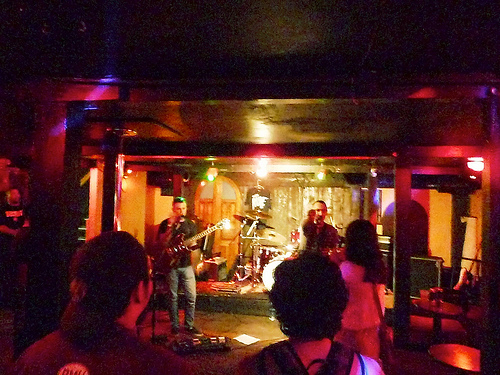<image>
Is there a pole next to the amp? Yes. The pole is positioned adjacent to the amp, located nearby in the same general area. 